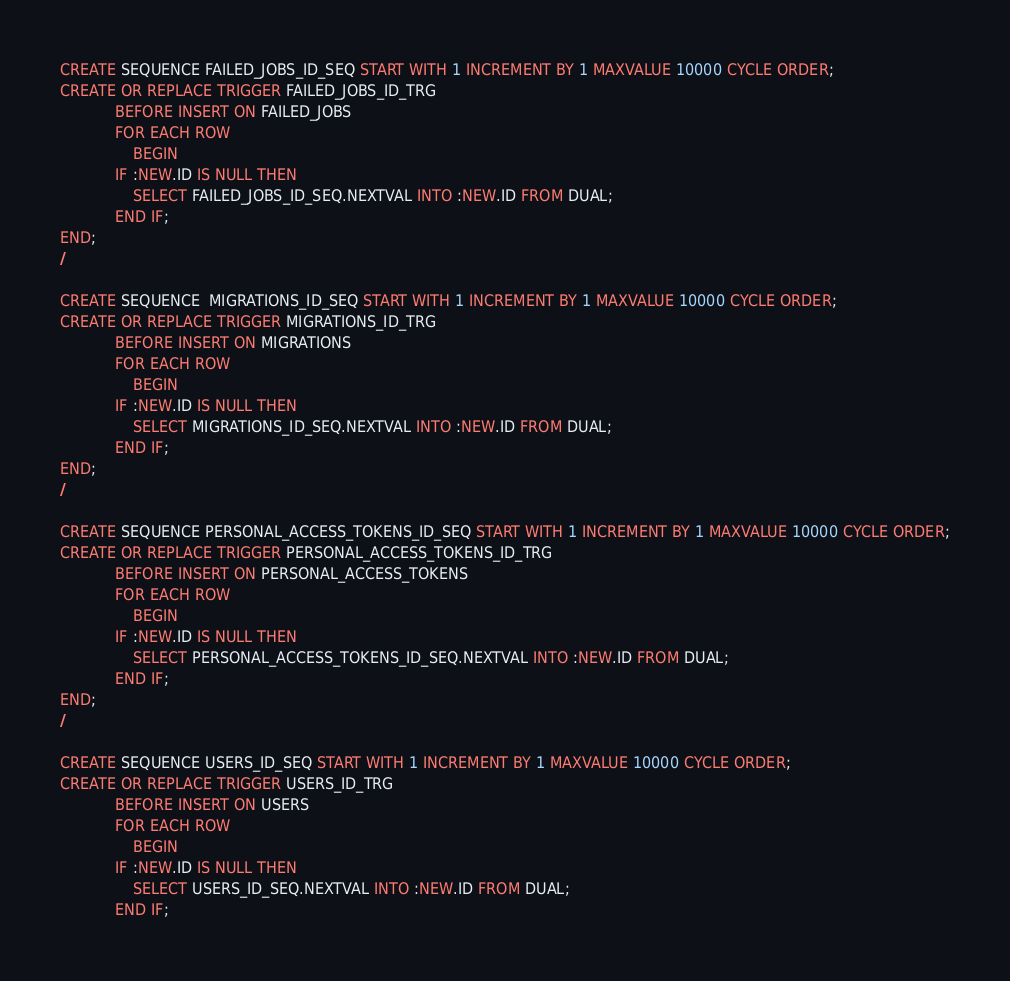<code> <loc_0><loc_0><loc_500><loc_500><_SQL_>CREATE SEQUENCE FAILED_JOBS_ID_SEQ START WITH 1 INCREMENT BY 1 MAXVALUE 10000 CYCLE ORDER;
CREATE OR REPLACE TRIGGER FAILED_JOBS_ID_TRG
            BEFORE INSERT ON FAILED_JOBS
            FOR EACH ROW
                BEGIN
            IF :NEW.ID IS NULL THEN
                SELECT FAILED_JOBS_ID_SEQ.NEXTVAL INTO :NEW.ID FROM DUAL;
            END IF;
END;
/

CREATE SEQUENCE  MIGRATIONS_ID_SEQ START WITH 1 INCREMENT BY 1 MAXVALUE 10000 CYCLE ORDER;
CREATE OR REPLACE TRIGGER MIGRATIONS_ID_TRG
            BEFORE INSERT ON MIGRATIONS
            FOR EACH ROW
                BEGIN
            IF :NEW.ID IS NULL THEN
                SELECT MIGRATIONS_ID_SEQ.NEXTVAL INTO :NEW.ID FROM DUAL;
            END IF;
END;
/

CREATE SEQUENCE PERSONAL_ACCESS_TOKENS_ID_SEQ START WITH 1 INCREMENT BY 1 MAXVALUE 10000 CYCLE ORDER;
CREATE OR REPLACE TRIGGER PERSONAL_ACCESS_TOKENS_ID_TRG
            BEFORE INSERT ON PERSONAL_ACCESS_TOKENS
            FOR EACH ROW
                BEGIN
            IF :NEW.ID IS NULL THEN
                SELECT PERSONAL_ACCESS_TOKENS_ID_SEQ.NEXTVAL INTO :NEW.ID FROM DUAL;
            END IF;
END;
/

CREATE SEQUENCE USERS_ID_SEQ START WITH 1 INCREMENT BY 1 MAXVALUE 10000 CYCLE ORDER;
CREATE OR REPLACE TRIGGER USERS_ID_TRG
            BEFORE INSERT ON USERS
            FOR EACH ROW
                BEGIN
            IF :NEW.ID IS NULL THEN
                SELECT USERS_ID_SEQ.NEXTVAL INTO :NEW.ID FROM DUAL;
            END IF;</code> 